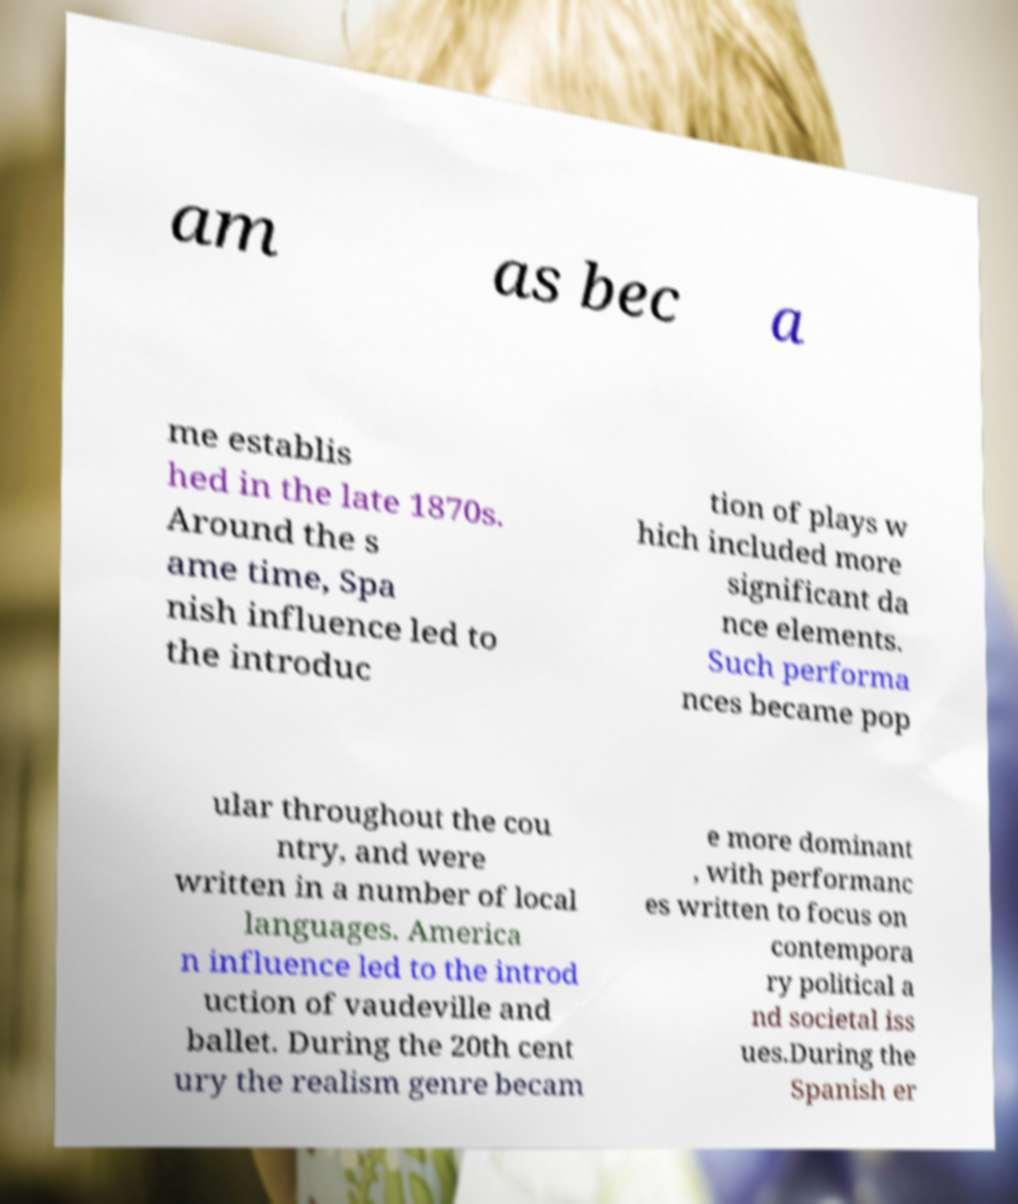Please identify and transcribe the text found in this image. am as bec a me establis hed in the late 1870s. Around the s ame time, Spa nish influence led to the introduc tion of plays w hich included more significant da nce elements. Such performa nces became pop ular throughout the cou ntry, and were written in a number of local languages. America n influence led to the introd uction of vaudeville and ballet. During the 20th cent ury the realism genre becam e more dominant , with performanc es written to focus on contempora ry political a nd societal iss ues.During the Spanish er 